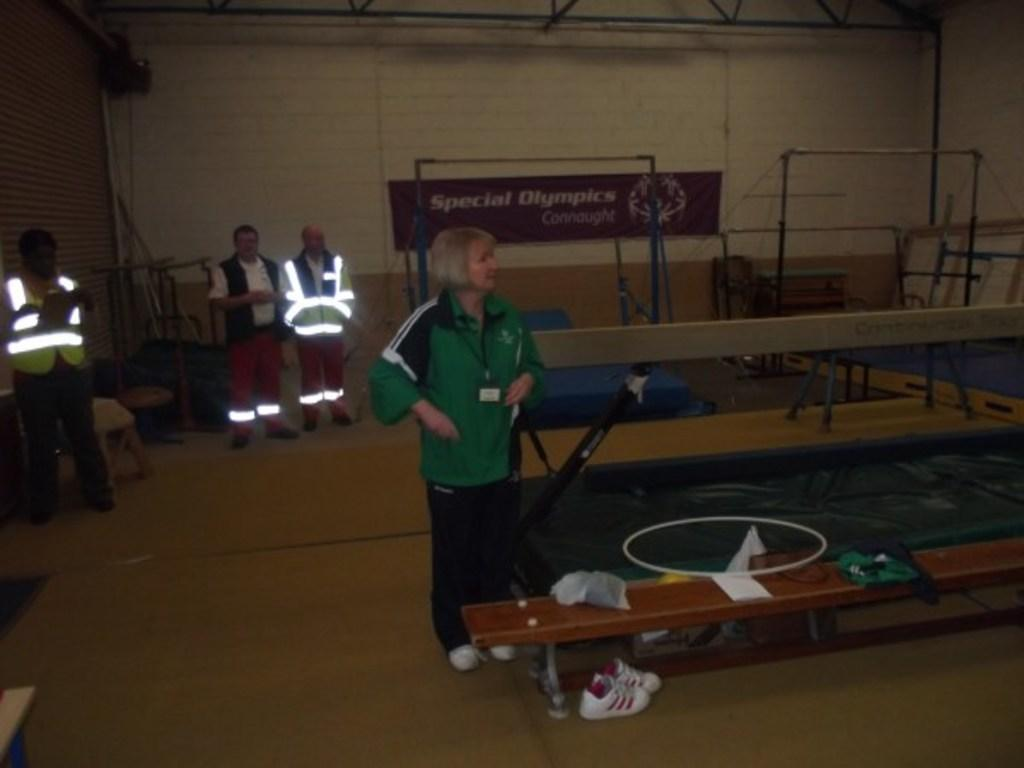What are the people in the image doing? The people in the image are standing. What object can be seen in the image that people might sit on? There is a bench in the image. Is there any other object in the image that might be related to the people? Yes, there is a shoe in the image. Can you see a stream flowing near the people in the image? No, there is no stream visible in the image. 